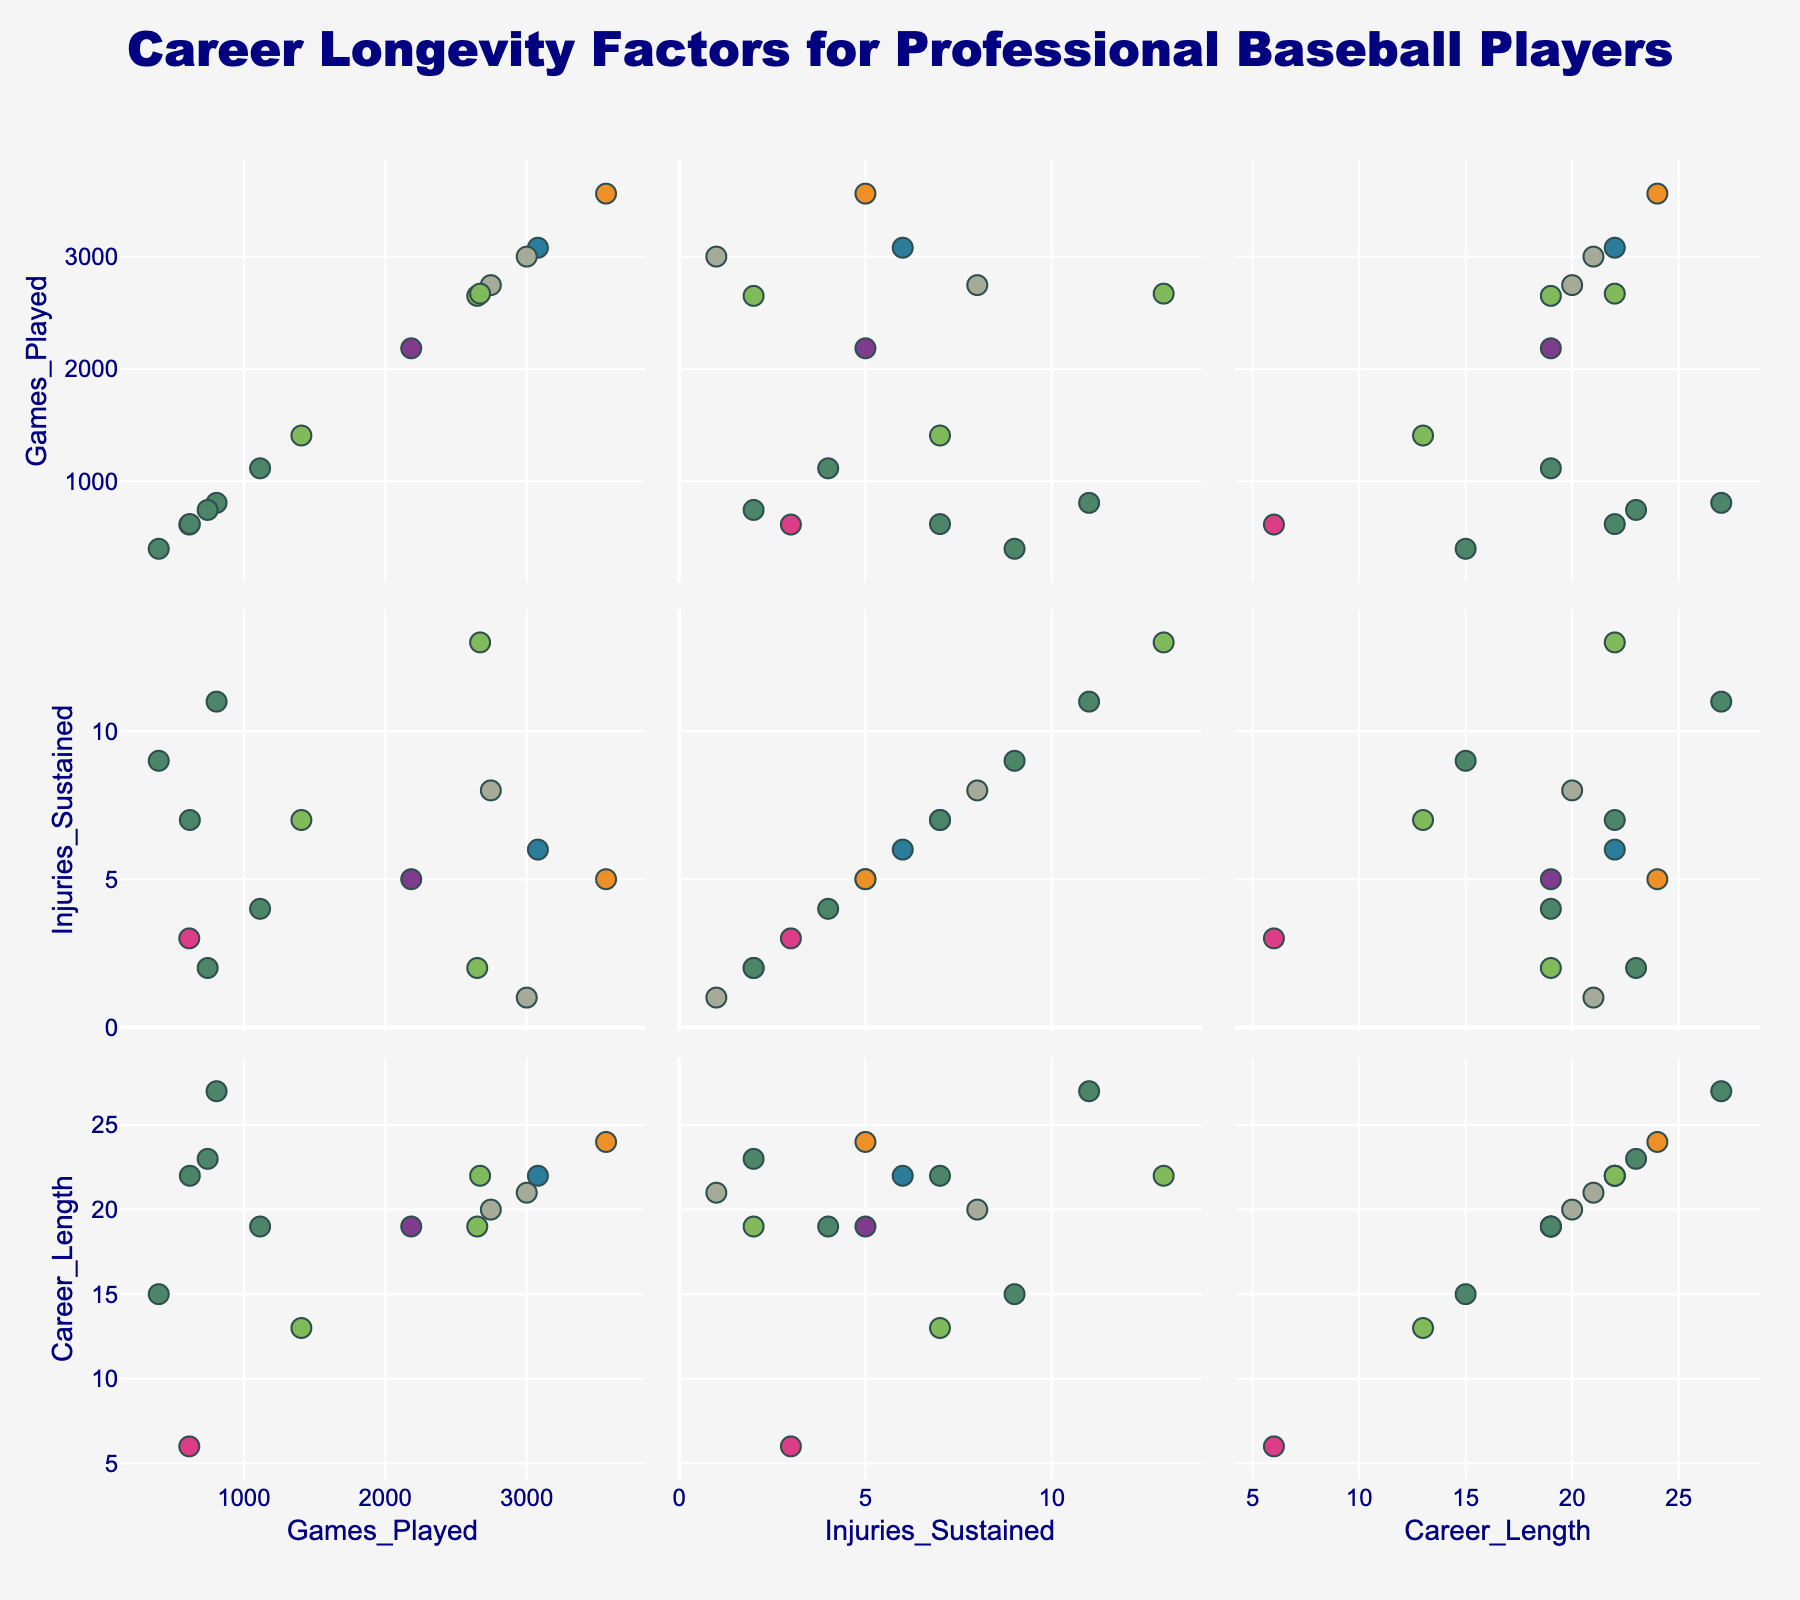What is the title of the plot? The title is located at the top center of the plot. It provides an overview of the focus of the visualization.
Answer: Career Longevity Factors for Professional Baseball Players How many players are depicted in the scatter plot matrix? Count the number of data points (markers) visible in each plot of the scatterplot matrix.
Answer: 14 Which player has the most games played? Look for the data point farthest to the right along the 'Games Played' axis across all three scatter plots in the first column. Identify the player associated with this point.
Answer: Pete Rose What position appears to have the longest career length on average? Identify the clusters of points by the position legend. For each position, approximate the average 'Career Length' by visually inspecting the Y-values of the points in the scatter plot involving 'Career Length'.
Answer: Pitcher Is there a visible correlation between the number of games played and career length? Examine the scatter plot comparing 'Games Played' and 'Career Length'. Observe the overall trend of the data points.
Answer: Yes, a positive correlation Who has the highest number of injuries sustained? Look for the data point farthest to the right along the 'Injuries Sustained' axis across all three scatter plots in the second row. Identify the player associated with this point.
Answer: Ken Griffey Jr Do players with fewer injuries tend to have longer careers? Examine the scatter plot comparing 'Injuries Sustained' and 'Career Length'. Look for a general trend where fewer injuries correspond to longer careers.
Answer: Yes Which position has the most varied career lengths? Compare the spread (range) of the data points for 'Career Length' for each cluster of points by position in the scatter plot involving 'Career Length'.
Answer: Outfield What is the relationship between the number of games played and the number of injuries sustained? Examine the scatter plot comparing 'Games Played' and 'Injuries Sustained'. Determine if there is a visible trend or pattern.
Answer: No clear trend Which two players have a similar number of games played but significantly different career lengths? Find two data points close together on the 'Games Played' axis but far apart on the 'Career Length' axis within the scatter plot comparing these two variables. Identify the associated players.
Answer: Shohei Ohtani and Randy Johnson 